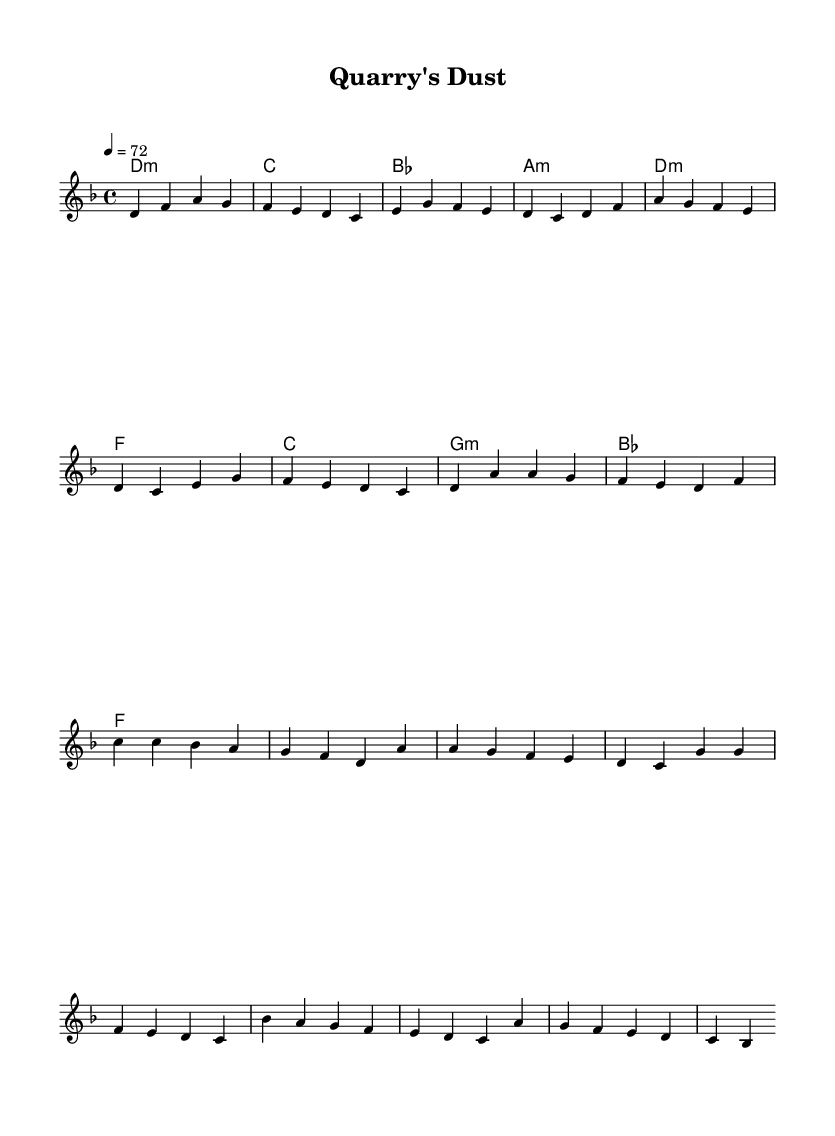What is the key signature of this music? The key signature is D minor, which has one flat (B flat).
Answer: D minor What is the time signature of this piece? The time signature is 4/4, indicating four beats per measure.
Answer: 4/4 What is the tempo marking of this music? The tempo marking indicates a speed of 72 beats per minute, which is a moderate pace.
Answer: 72 How many measures are there in the chorus section? The chorus section consists of 4 measures, as indicated by the repeated phrases.
Answer: 4 What is the first chord in the verse? The first chord in the verse is D minor, shown at the beginning of the melody.
Answer: D minor Which two chords occur consecutively in the chorus? The two chords that occur consecutively in the chorus are F major and C major, as seen in the chord progression.
Answer: F major, C major What is the last note of the bridge? The last note of the bridge is B flat, which is indicated in the melody before it transitions back to the chorus.
Answer: B flat 